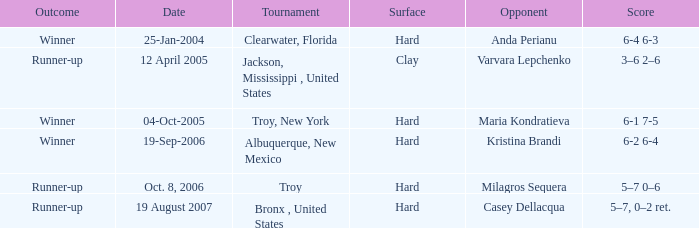What was the game score when playing against maria kondratieva? 6-1 7-5. 